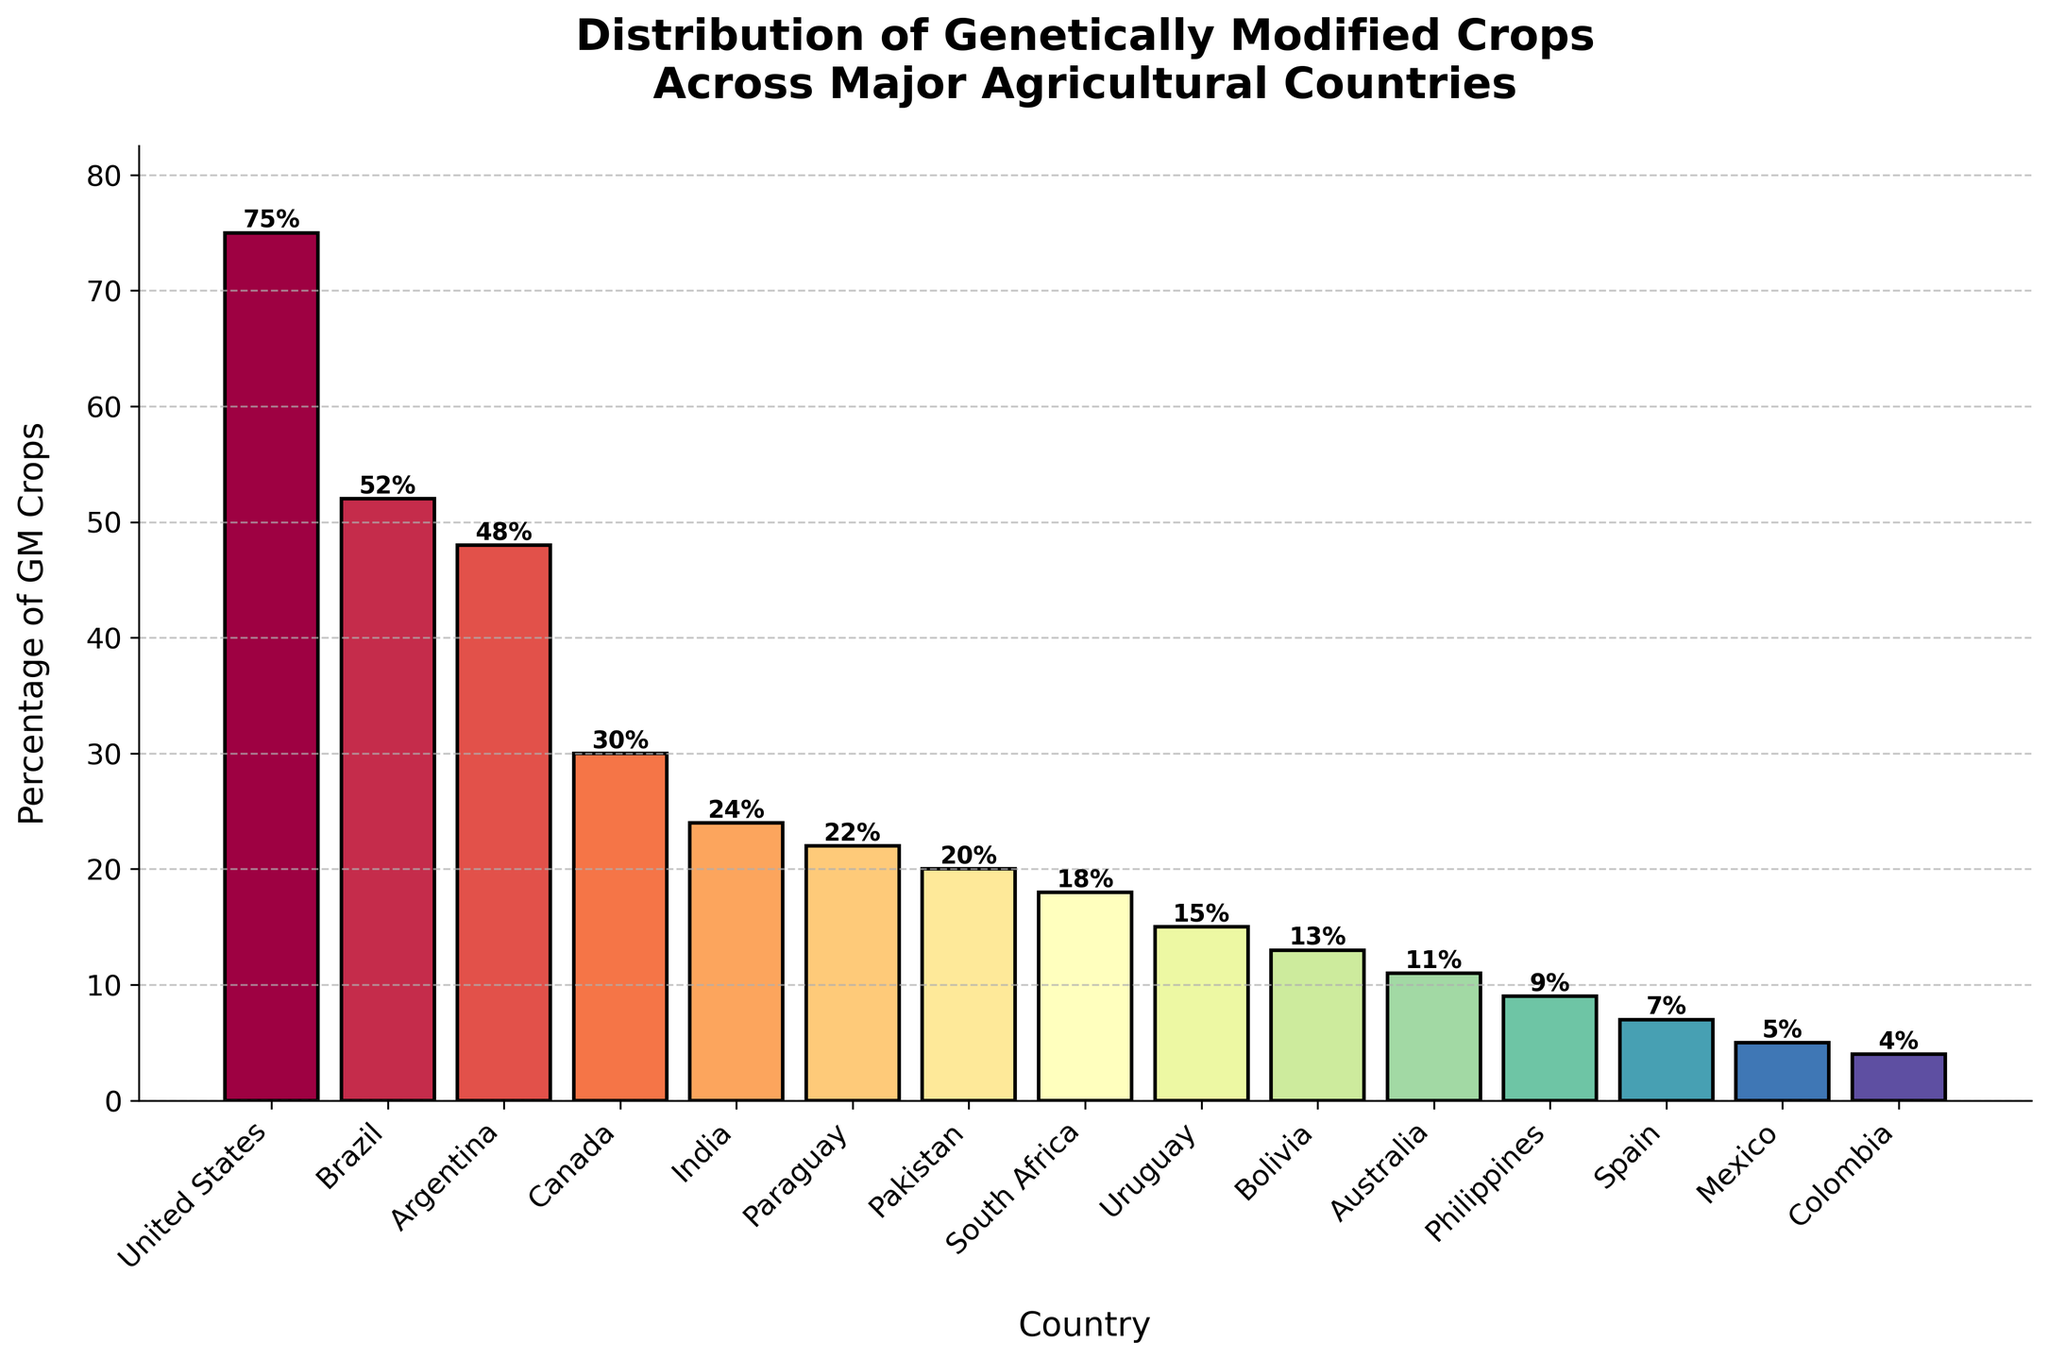What country has the highest percentage of genetically modified crops? The figure shows several countries with their respective percentages of genetically modified (GM) crops. By looking at the heights of the bars, the United States has the highest bar at 75%.
Answer: United States Which two countries have the closest percentages of GM crops? To determine this, look for bars that have similar heights. Upon inspection, Argentina (48%) and Canada (30%) are fairly close, but Canada (30%) and India (24%) have a closer difference.
Answer: Canada and India What is the difference in percentage of GM crops between Brazil and Argentina? By reading the values from the figure, Brazil has 52% and Argentina has 48%. The difference is obtained by subtracting these values 52% - 48% = 4%.
Answer: 4% Which country has the lowest percentage of genetically modified crops? The figure presents the lowest bar for Colombia at 4%.
Answer: Colombia How does the percentage of GM crops in Paraguay compare to that in Australia? From the figure, Paraguay has 22% and Australia has 11%. Paraguay's percentage is higher.
Answer: Paraguay has a higher percentage What is the average percentage of GM crops across all listed countries? To calculate this, sum all the percentages and divide by the number of countries. The percentages sum up to 359, and there are 15 countries: 359 / 15 ≈ 23.93%.
Answer: 23.93% What is the total combined percentage of GM crops for the top three countries? The top three countries are the United States (75%), Brazil (52%), and Argentina (48%). Adding these together gives 75 + 52 + 48 = 175.
Answer: 175% Which country has a GM crop percentage close to the global average calculated previously? The global average is approximately 23.93%. Looking at the bars, India (24%) is closest to this average.
Answer: India Compare the percentage of GM crops between the top country and the lowest country. The United States has 75% and Colombia has 4%. The difference between them is calculated as 75% - 4% = 71%.
Answer: 71% Is the percentage of GM crops in Pakistan higher, lower, or equal to that in South Africa? By examining the bars, Pakistan has 20% and South Africa has 18%. Pakistan's percentage is slightly higher than South Africa's.
Answer: Pakistan has a higher percentage 